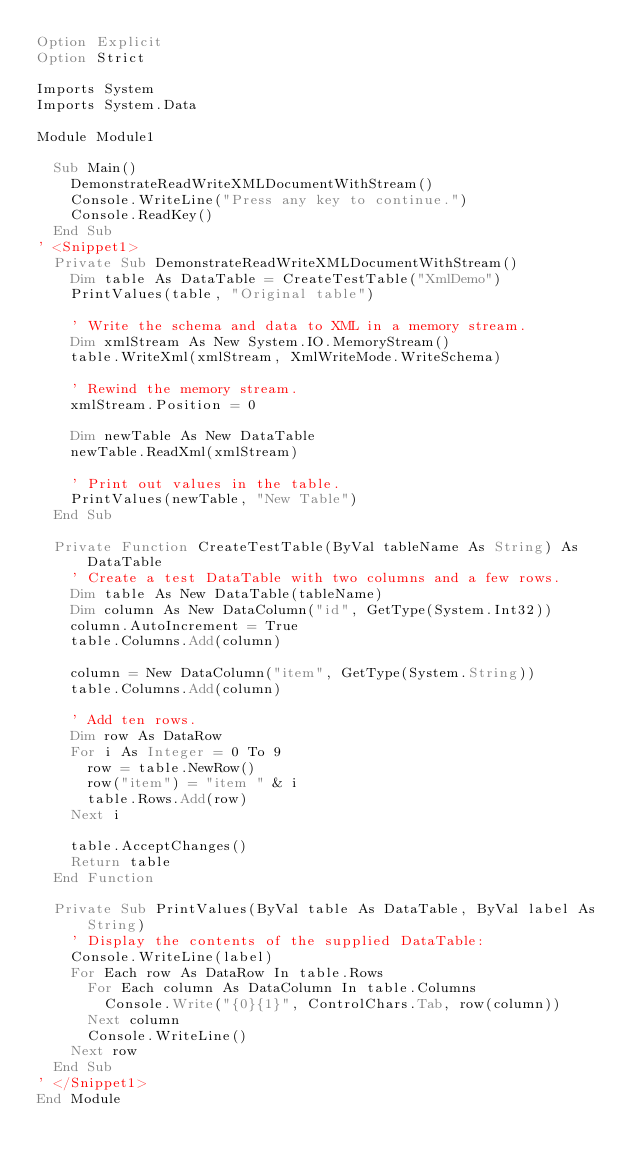Convert code to text. <code><loc_0><loc_0><loc_500><loc_500><_VisualBasic_>Option Explicit
Option Strict

Imports System
Imports System.Data
   
Module Module1

  Sub Main()
    DemonstrateReadWriteXMLDocumentWithStream()
    Console.WriteLine("Press any key to continue.")
    Console.ReadKey()
  End Sub
' <Snippet1>
  Private Sub DemonstrateReadWriteXMLDocumentWithStream()
    Dim table As DataTable = CreateTestTable("XmlDemo")
    PrintValues(table, "Original table")

    ' Write the schema and data to XML in a memory stream.
    Dim xmlStream As New System.IO.MemoryStream()
    table.WriteXml(xmlStream, XmlWriteMode.WriteSchema)

    ' Rewind the memory stream.
    xmlStream.Position = 0

    Dim newTable As New DataTable
    newTable.ReadXml(xmlStream)

    ' Print out values in the table.
    PrintValues(newTable, "New Table")
  End Sub

  Private Function CreateTestTable(ByVal tableName As String) As DataTable
    ' Create a test DataTable with two columns and a few rows.
    Dim table As New DataTable(tableName)
    Dim column As New DataColumn("id", GetType(System.Int32))
    column.AutoIncrement = True
    table.Columns.Add(column)

    column = New DataColumn("item", GetType(System.String))
    table.Columns.Add(column)

    ' Add ten rows.
    Dim row As DataRow
    For i As Integer = 0 To 9
      row = table.NewRow()
      row("item") = "item " & i
      table.Rows.Add(row)
    Next i

    table.AcceptChanges()
    Return table
  End Function

  Private Sub PrintValues(ByVal table As DataTable, ByVal label As String)
    ' Display the contents of the supplied DataTable:
    Console.WriteLine(label)
    For Each row As DataRow In table.Rows
      For Each column As DataColumn In table.Columns
        Console.Write("{0}{1}", ControlChars.Tab, row(column))
      Next column
      Console.WriteLine()
    Next row
  End Sub
' </Snippet1>
End Module

</code> 